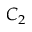<formula> <loc_0><loc_0><loc_500><loc_500>C _ { 2 }</formula> 